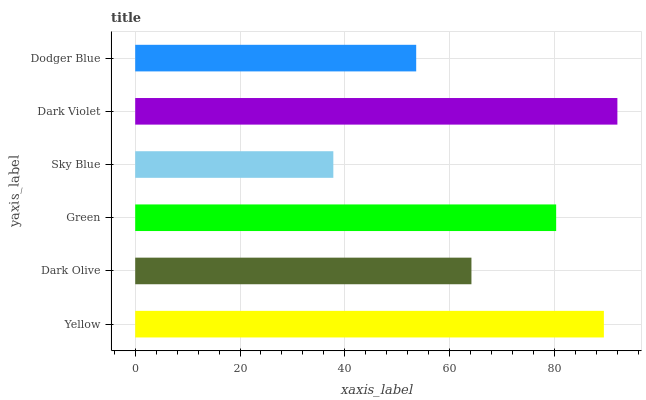Is Sky Blue the minimum?
Answer yes or no. Yes. Is Dark Violet the maximum?
Answer yes or no. Yes. Is Dark Olive the minimum?
Answer yes or no. No. Is Dark Olive the maximum?
Answer yes or no. No. Is Yellow greater than Dark Olive?
Answer yes or no. Yes. Is Dark Olive less than Yellow?
Answer yes or no. Yes. Is Dark Olive greater than Yellow?
Answer yes or no. No. Is Yellow less than Dark Olive?
Answer yes or no. No. Is Green the high median?
Answer yes or no. Yes. Is Dark Olive the low median?
Answer yes or no. Yes. Is Dark Violet the high median?
Answer yes or no. No. Is Dodger Blue the low median?
Answer yes or no. No. 